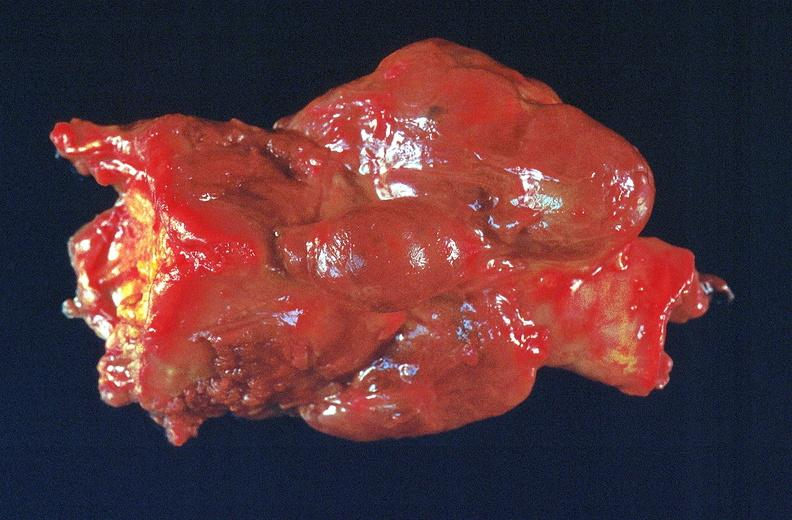s endocrine present?
Answer the question using a single word or phrase. Yes 